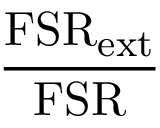Convert formula to latex. <formula><loc_0><loc_0><loc_500><loc_500>\frac { F S R _ { e x t } } { F S R }</formula> 